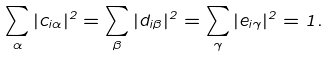<formula> <loc_0><loc_0><loc_500><loc_500>\sum _ { \alpha } | c _ { i \alpha } | ^ { 2 } = \sum _ { \beta } | d _ { i \beta } | ^ { 2 } = \sum _ { \gamma } | e _ { i \gamma } | ^ { 2 } = 1 .</formula> 